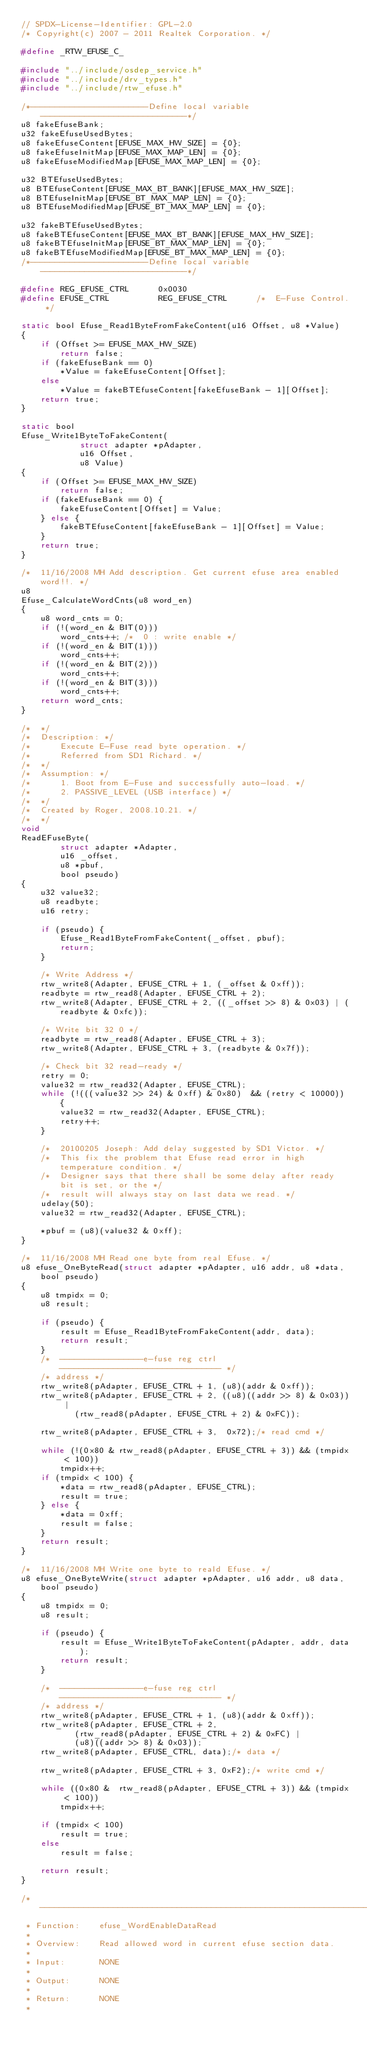Convert code to text. <code><loc_0><loc_0><loc_500><loc_500><_C_>// SPDX-License-Identifier: GPL-2.0
/* Copyright(c) 2007 - 2011 Realtek Corporation. */

#define _RTW_EFUSE_C_

#include "../include/osdep_service.h"
#include "../include/drv_types.h"
#include "../include/rtw_efuse.h"

/*------------------------Define local variable------------------------------*/
u8 fakeEfuseBank;
u32 fakeEfuseUsedBytes;
u8 fakeEfuseContent[EFUSE_MAX_HW_SIZE] = {0};
u8 fakeEfuseInitMap[EFUSE_MAX_MAP_LEN] = {0};
u8 fakeEfuseModifiedMap[EFUSE_MAX_MAP_LEN] = {0};

u32 BTEfuseUsedBytes;
u8 BTEfuseContent[EFUSE_MAX_BT_BANK][EFUSE_MAX_HW_SIZE];
u8 BTEfuseInitMap[EFUSE_BT_MAX_MAP_LEN] = {0};
u8 BTEfuseModifiedMap[EFUSE_BT_MAX_MAP_LEN] = {0};

u32 fakeBTEfuseUsedBytes;
u8 fakeBTEfuseContent[EFUSE_MAX_BT_BANK][EFUSE_MAX_HW_SIZE];
u8 fakeBTEfuseInitMap[EFUSE_BT_MAX_MAP_LEN] = {0};
u8 fakeBTEfuseModifiedMap[EFUSE_BT_MAX_MAP_LEN] = {0};
/*------------------------Define local variable------------------------------*/

#define REG_EFUSE_CTRL		0x0030
#define EFUSE_CTRL			REG_EFUSE_CTRL		/*  E-Fuse Control. */

static bool Efuse_Read1ByteFromFakeContent(u16 Offset, u8 *Value)
{
	if (Offset >= EFUSE_MAX_HW_SIZE)
		return false;
	if (fakeEfuseBank == 0)
		*Value = fakeEfuseContent[Offset];
	else
		*Value = fakeBTEfuseContent[fakeEfuseBank - 1][Offset];
	return true;
}

static bool
Efuse_Write1ByteToFakeContent(
			struct adapter *pAdapter,
			u16 Offset,
			u8 Value)
{
	if (Offset >= EFUSE_MAX_HW_SIZE)
		return false;
	if (fakeEfuseBank == 0) {
		fakeEfuseContent[Offset] = Value;
	} else {
		fakeBTEfuseContent[fakeEfuseBank - 1][Offset] = Value;
	}
	return true;
}

/*  11/16/2008 MH Add description. Get current efuse area enabled word!!. */
u8
Efuse_CalculateWordCnts(u8 word_en)
{
	u8 word_cnts = 0;
	if (!(word_en & BIT(0)))
		word_cnts++; /*  0 : write enable */
	if (!(word_en & BIT(1)))
		word_cnts++;
	if (!(word_en & BIT(2)))
		word_cnts++;
	if (!(word_en & BIT(3)))
		word_cnts++;
	return word_cnts;
}

/*  */
/* 	Description: */
/* 		Execute E-Fuse read byte operation. */
/* 		Referred from SD1 Richard. */
/*  */
/* 	Assumption: */
/* 		1. Boot from E-Fuse and successfully auto-load. */
/* 		2. PASSIVE_LEVEL (USB interface) */
/*  */
/* 	Created by Roger, 2008.10.21. */
/*  */
void
ReadEFuseByte(
		struct adapter *Adapter,
		u16 _offset,
		u8 *pbuf,
		bool pseudo)
{
	u32 value32;
	u8 readbyte;
	u16 retry;

	if (pseudo) {
		Efuse_Read1ByteFromFakeContent(_offset, pbuf);
		return;
	}

	/* Write Address */
	rtw_write8(Adapter, EFUSE_CTRL + 1, (_offset & 0xff));
	readbyte = rtw_read8(Adapter, EFUSE_CTRL + 2);
	rtw_write8(Adapter, EFUSE_CTRL + 2, ((_offset >> 8) & 0x03) | (readbyte & 0xfc));

	/* Write bit 32 0 */
	readbyte = rtw_read8(Adapter, EFUSE_CTRL + 3);
	rtw_write8(Adapter, EFUSE_CTRL + 3, (readbyte & 0x7f));

	/* Check bit 32 read-ready */
	retry = 0;
	value32 = rtw_read32(Adapter, EFUSE_CTRL);
	while (!(((value32 >> 24) & 0xff) & 0x80)  && (retry < 10000)) {
		value32 = rtw_read32(Adapter, EFUSE_CTRL);
		retry++;
	}

	/*  20100205 Joseph: Add delay suggested by SD1 Victor. */
	/*  This fix the problem that Efuse read error in high temperature condition. */
	/*  Designer says that there shall be some delay after ready bit is set, or the */
	/*  result will always stay on last data we read. */
	udelay(50);
	value32 = rtw_read32(Adapter, EFUSE_CTRL);

	*pbuf = (u8)(value32 & 0xff);
}

/*  11/16/2008 MH Read one byte from real Efuse. */
u8 efuse_OneByteRead(struct adapter *pAdapter, u16 addr, u8 *data, bool pseudo)
{
	u8 tmpidx = 0;
	u8 result;

	if (pseudo) {
		result = Efuse_Read1ByteFromFakeContent(addr, data);
		return result;
	}
	/*  -----------------e-fuse reg ctrl --------------------------------- */
	/* address */
	rtw_write8(pAdapter, EFUSE_CTRL + 1, (u8)(addr & 0xff));
	rtw_write8(pAdapter, EFUSE_CTRL + 2, ((u8)((addr >> 8) & 0x03)) |
		   (rtw_read8(pAdapter, EFUSE_CTRL + 2) & 0xFC));

	rtw_write8(pAdapter, EFUSE_CTRL + 3,  0x72);/* read cmd */

	while (!(0x80 & rtw_read8(pAdapter, EFUSE_CTRL + 3)) && (tmpidx < 100))
		tmpidx++;
	if (tmpidx < 100) {
		*data = rtw_read8(pAdapter, EFUSE_CTRL);
		result = true;
	} else {
		*data = 0xff;
		result = false;
	}
	return result;
}

/*  11/16/2008 MH Write one byte to reald Efuse. */
u8 efuse_OneByteWrite(struct adapter *pAdapter, u16 addr, u8 data, bool pseudo)
{
	u8 tmpidx = 0;
	u8 result;

	if (pseudo) {
		result = Efuse_Write1ByteToFakeContent(pAdapter, addr, data);
		return result;
	}

	/*  -----------------e-fuse reg ctrl --------------------------------- */
	/* address */
	rtw_write8(pAdapter, EFUSE_CTRL + 1, (u8)(addr & 0xff));
	rtw_write8(pAdapter, EFUSE_CTRL + 2,
		   (rtw_read8(pAdapter, EFUSE_CTRL + 2) & 0xFC) |
		   (u8)((addr >> 8) & 0x03));
	rtw_write8(pAdapter, EFUSE_CTRL, data);/* data */

	rtw_write8(pAdapter, EFUSE_CTRL + 3, 0xF2);/* write cmd */

	while ((0x80 &  rtw_read8(pAdapter, EFUSE_CTRL + 3)) && (tmpidx < 100))
		tmpidx++;

	if (tmpidx < 100)
		result = true;
	else
		result = false;

	return result;
}

/*-----------------------------------------------------------------------------
 * Function:	efuse_WordEnableDataRead
 *
 * Overview:	Read allowed word in current efuse section data.
 *
 * Input:       NONE
 *
 * Output:      NONE
 *
 * Return:      NONE
 *</code> 